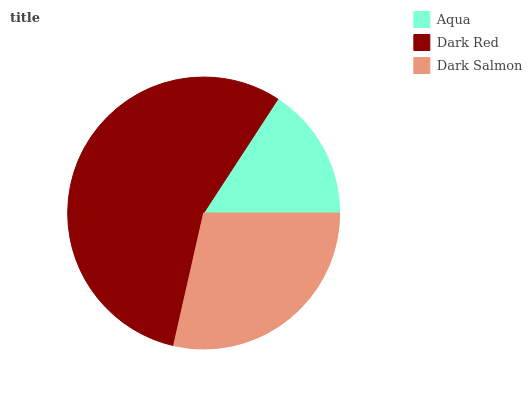Is Aqua the minimum?
Answer yes or no. Yes. Is Dark Red the maximum?
Answer yes or no. Yes. Is Dark Salmon the minimum?
Answer yes or no. No. Is Dark Salmon the maximum?
Answer yes or no. No. Is Dark Red greater than Dark Salmon?
Answer yes or no. Yes. Is Dark Salmon less than Dark Red?
Answer yes or no. Yes. Is Dark Salmon greater than Dark Red?
Answer yes or no. No. Is Dark Red less than Dark Salmon?
Answer yes or no. No. Is Dark Salmon the high median?
Answer yes or no. Yes. Is Dark Salmon the low median?
Answer yes or no. Yes. Is Dark Red the high median?
Answer yes or no. No. Is Aqua the low median?
Answer yes or no. No. 